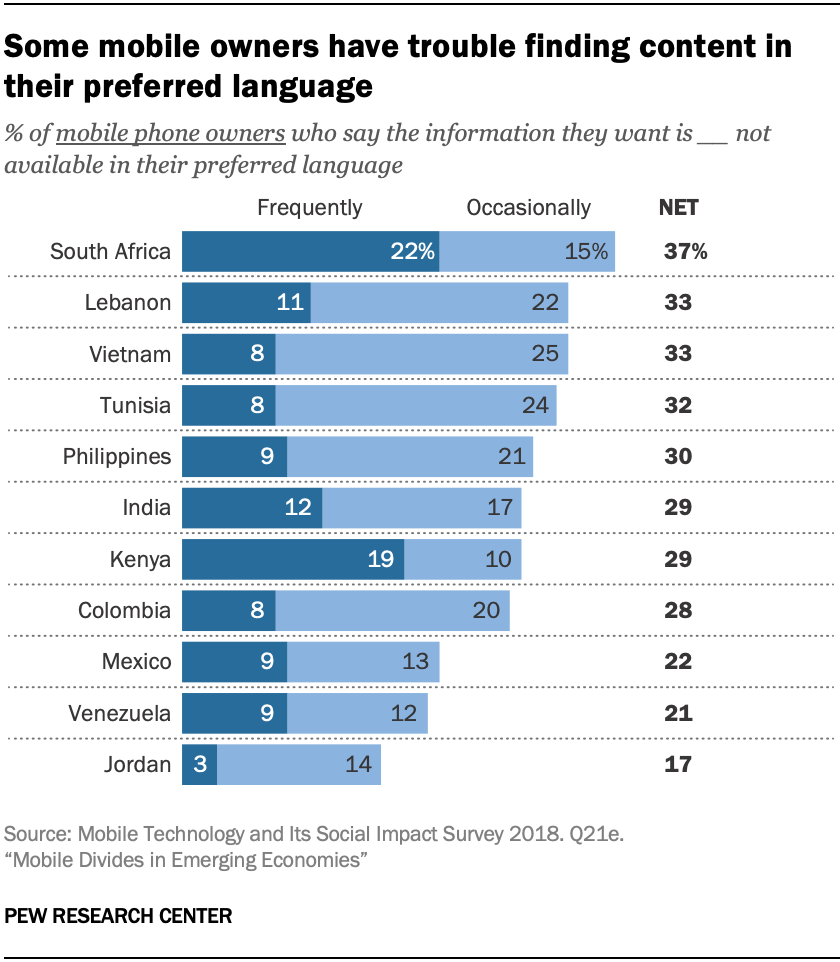Identify some key points in this picture. A significant percentage of people in Lebanon frequently choose to consume cannabis. In how many countries does the percentage of people who choose Frequently exceed 10? 